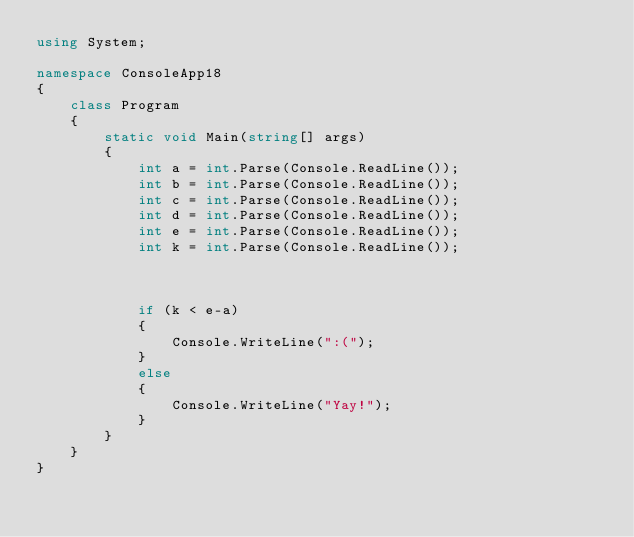Convert code to text. <code><loc_0><loc_0><loc_500><loc_500><_C#_>using System;

namespace ConsoleApp18
{
    class Program
    {
        static void Main(string[] args)
        {
            int a = int.Parse(Console.ReadLine());
            int b = int.Parse(Console.ReadLine());
            int c = int.Parse(Console.ReadLine());
            int d = int.Parse(Console.ReadLine());
            int e = int.Parse(Console.ReadLine());
            int k = int.Parse(Console.ReadLine());

            

            if (k < e-a)
            {
                Console.WriteLine(":(");
            }
            else
            {
                Console.WriteLine("Yay!");
            }
        }
    }
}</code> 